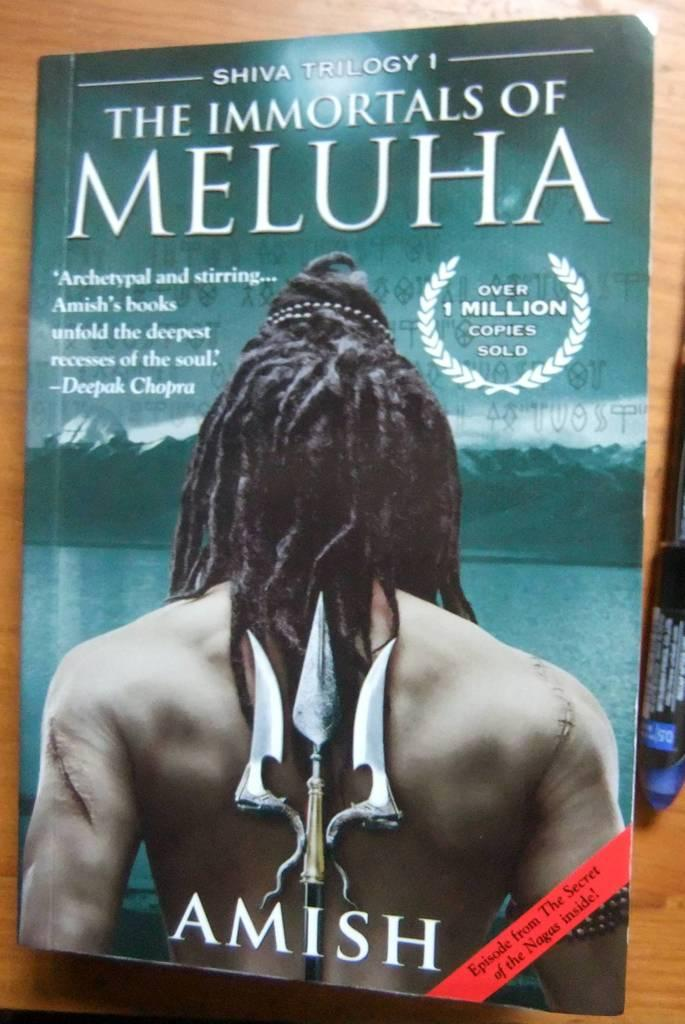<image>
Offer a succinct explanation of the picture presented. a novel writen by Amish titled the immortals of meluha. 